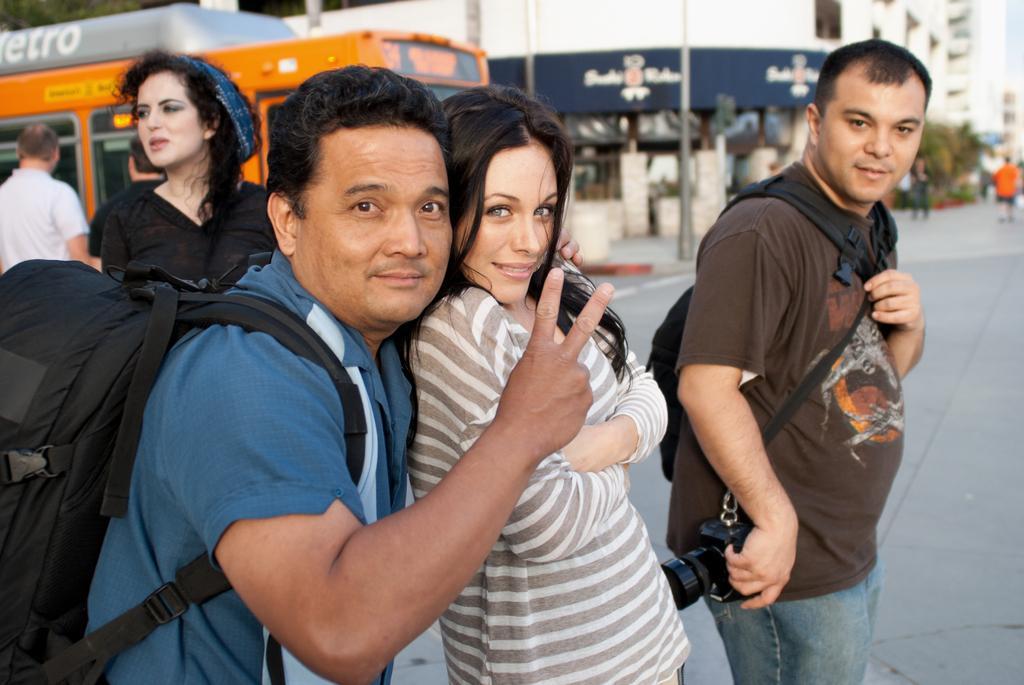Please provide a concise description of this image. In this picture I can observe some people in the middle of the picture. There are men and women in this picture. In the background I can observe building. 